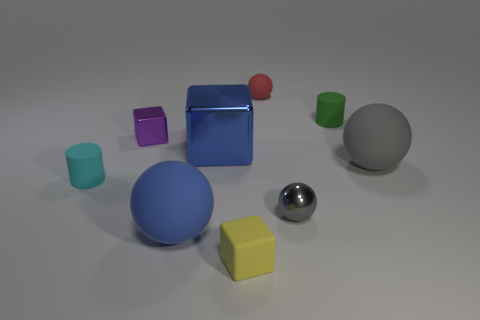Subtract all blue balls. How many balls are left? 3 Subtract all purple blocks. How many blocks are left? 2 Add 1 small blue things. How many objects exist? 10 Subtract 1 blocks. How many blocks are left? 2 Subtract all brown cylinders. How many purple blocks are left? 1 Subtract all gray balls. Subtract all small matte cylinders. How many objects are left? 5 Add 3 metal balls. How many metal balls are left? 4 Add 7 cyan rubber cylinders. How many cyan rubber cylinders exist? 8 Subtract 1 purple cubes. How many objects are left? 8 Subtract all cylinders. How many objects are left? 7 